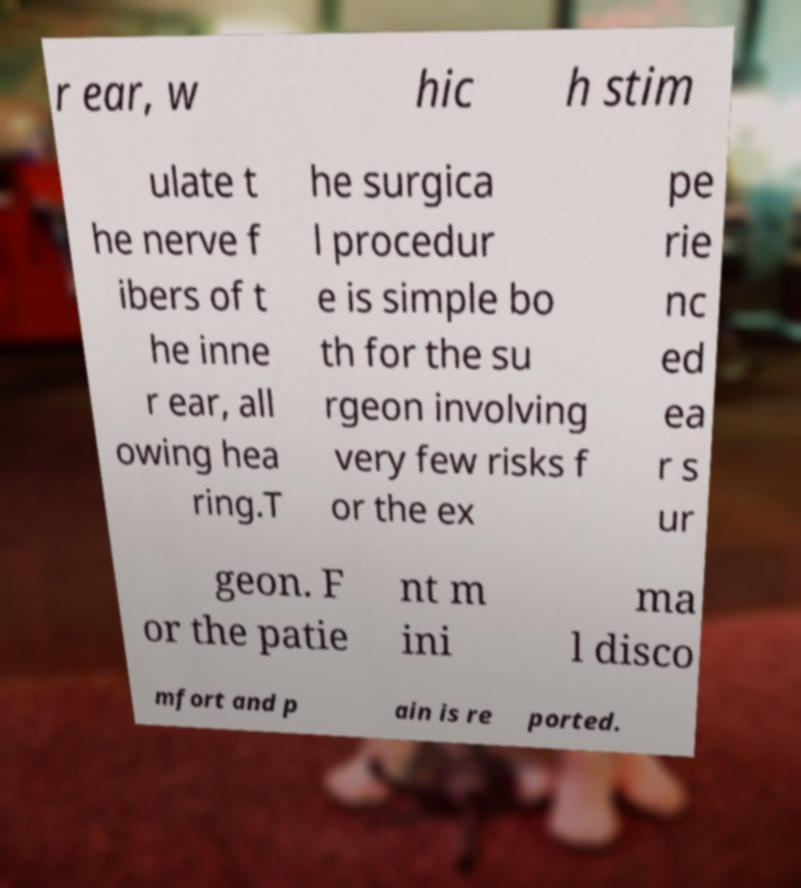Can you read and provide the text displayed in the image?This photo seems to have some interesting text. Can you extract and type it out for me? r ear, w hic h stim ulate t he nerve f ibers of t he inne r ear, all owing hea ring.T he surgica l procedur e is simple bo th for the su rgeon involving very few risks f or the ex pe rie nc ed ea r s ur geon. F or the patie nt m ini ma l disco mfort and p ain is re ported. 